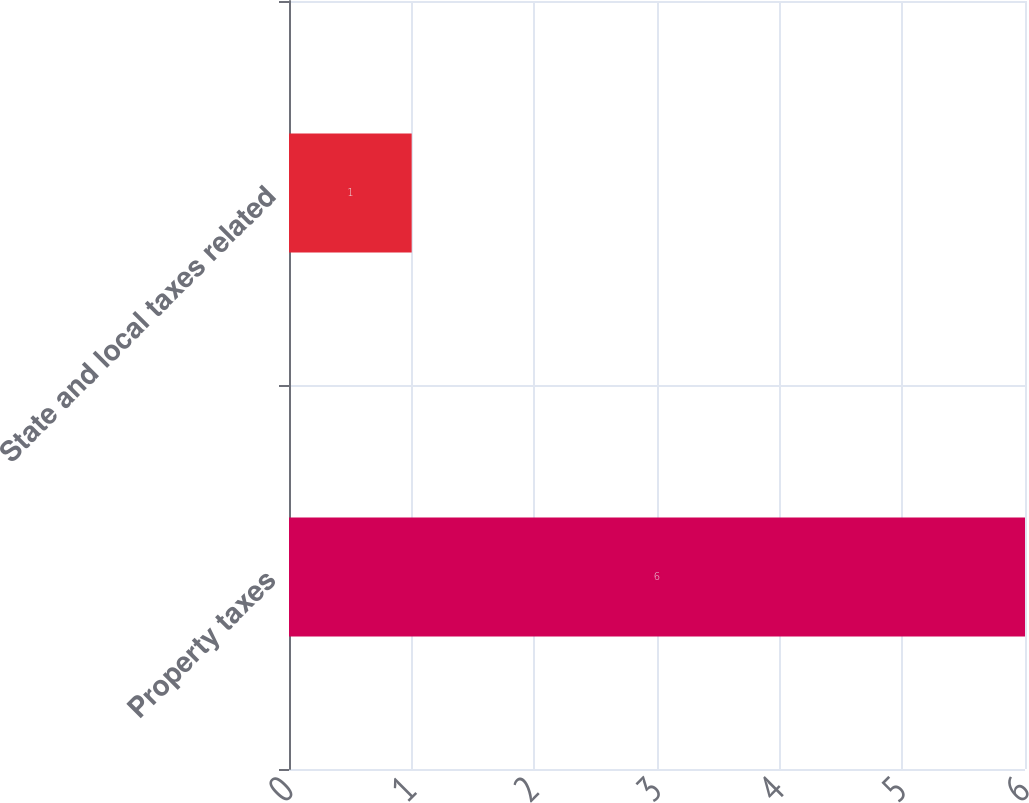Convert chart to OTSL. <chart><loc_0><loc_0><loc_500><loc_500><bar_chart><fcel>Property taxes<fcel>State and local taxes related<nl><fcel>6<fcel>1<nl></chart> 